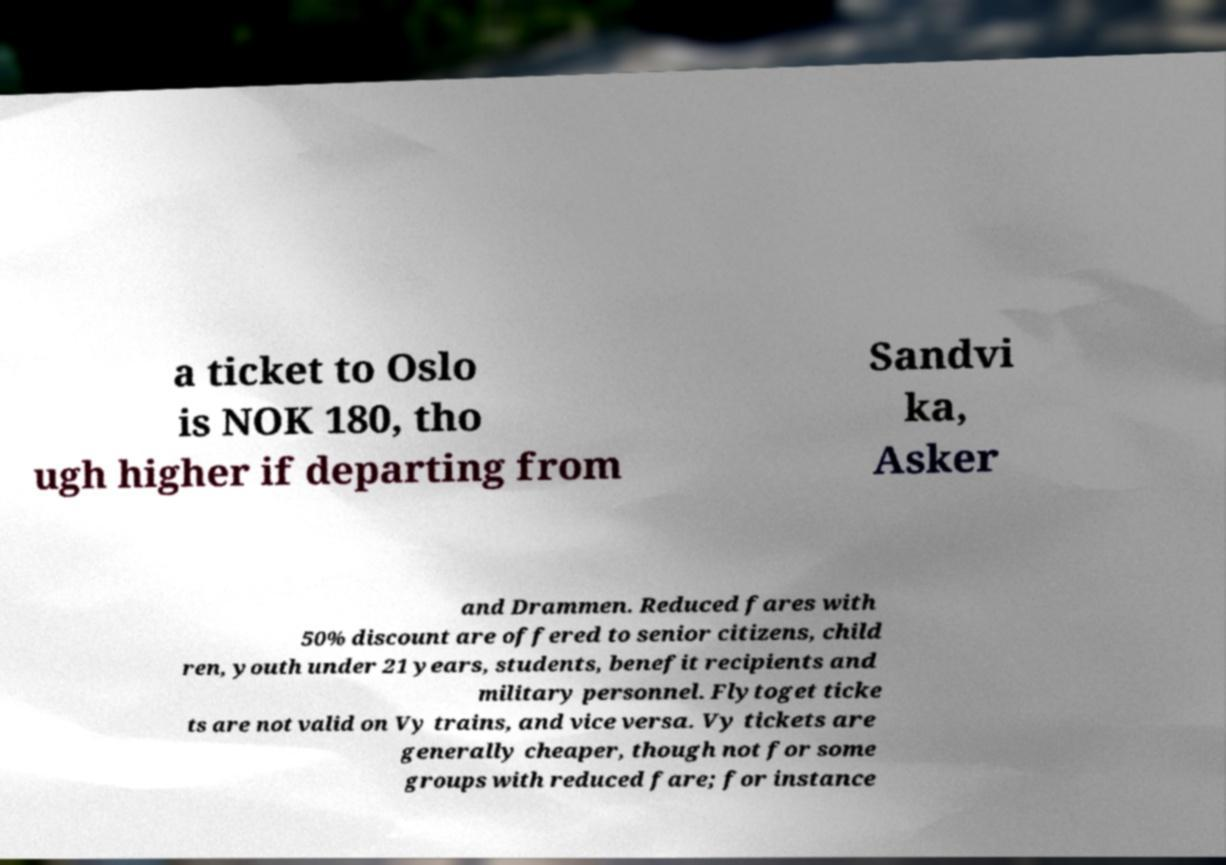What messages or text are displayed in this image? I need them in a readable, typed format. a ticket to Oslo is NOK 180, tho ugh higher if departing from Sandvi ka, Asker and Drammen. Reduced fares with 50% discount are offered to senior citizens, child ren, youth under 21 years, students, benefit recipients and military personnel. Flytoget ticke ts are not valid on Vy trains, and vice versa. Vy tickets are generally cheaper, though not for some groups with reduced fare; for instance 